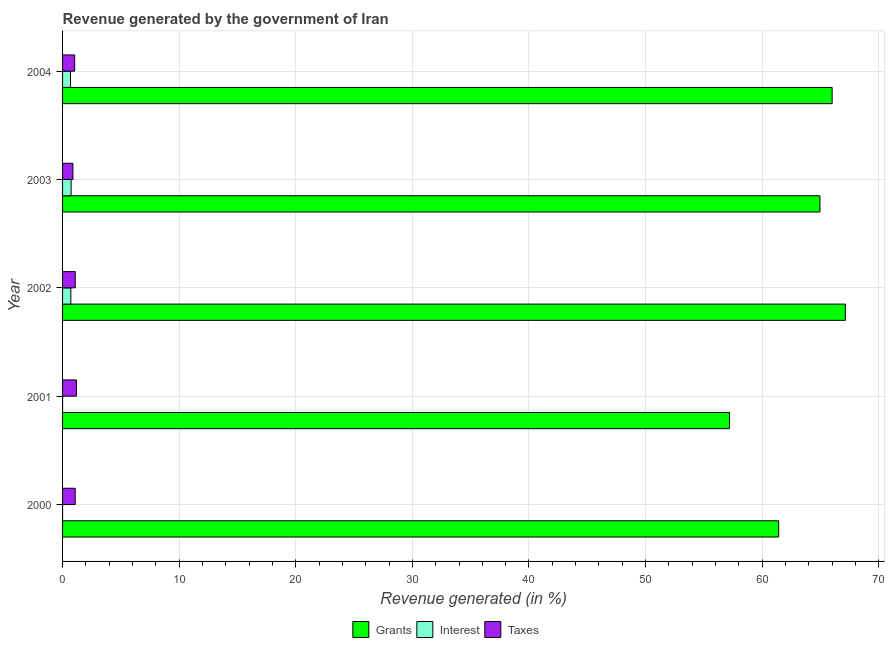How many different coloured bars are there?
Keep it short and to the point. 3. How many groups of bars are there?
Make the answer very short. 5. How many bars are there on the 2nd tick from the top?
Make the answer very short. 3. How many bars are there on the 2nd tick from the bottom?
Make the answer very short. 3. What is the label of the 1st group of bars from the top?
Your response must be concise. 2004. What is the percentage of revenue generated by grants in 2002?
Keep it short and to the point. 67.13. Across all years, what is the maximum percentage of revenue generated by grants?
Your answer should be compact. 67.13. Across all years, what is the minimum percentage of revenue generated by grants?
Keep it short and to the point. 57.2. What is the total percentage of revenue generated by interest in the graph?
Offer a very short reply. 2.12. What is the difference between the percentage of revenue generated by taxes in 2002 and that in 2004?
Ensure brevity in your answer.  0.05. What is the difference between the percentage of revenue generated by grants in 2002 and the percentage of revenue generated by taxes in 2004?
Ensure brevity in your answer.  66.1. What is the average percentage of revenue generated by taxes per year?
Your answer should be very brief. 1.06. In the year 2002, what is the difference between the percentage of revenue generated by grants and percentage of revenue generated by taxes?
Your answer should be compact. 66.05. In how many years, is the percentage of revenue generated by grants greater than 36 %?
Your answer should be very brief. 5. What is the ratio of the percentage of revenue generated by taxes in 2003 to that in 2004?
Make the answer very short. 0.85. What is the difference between the highest and the second highest percentage of revenue generated by grants?
Make the answer very short. 1.13. What is the difference between the highest and the lowest percentage of revenue generated by interest?
Provide a succinct answer. 0.73. What does the 2nd bar from the top in 2002 represents?
Provide a short and direct response. Interest. What does the 3rd bar from the bottom in 2001 represents?
Provide a succinct answer. Taxes. Is it the case that in every year, the sum of the percentage of revenue generated by grants and percentage of revenue generated by interest is greater than the percentage of revenue generated by taxes?
Provide a short and direct response. Yes. Does the graph contain grids?
Provide a succinct answer. Yes. Where does the legend appear in the graph?
Keep it short and to the point. Bottom center. How many legend labels are there?
Your response must be concise. 3. How are the legend labels stacked?
Offer a terse response. Horizontal. What is the title of the graph?
Give a very brief answer. Revenue generated by the government of Iran. Does "Czech Republic" appear as one of the legend labels in the graph?
Your answer should be very brief. No. What is the label or title of the X-axis?
Your response must be concise. Revenue generated (in %). What is the label or title of the Y-axis?
Offer a terse response. Year. What is the Revenue generated (in %) in Grants in 2000?
Your answer should be compact. 61.42. What is the Revenue generated (in %) of Interest in 2000?
Keep it short and to the point. 5.52099100195348e-5. What is the Revenue generated (in %) in Taxes in 2000?
Your answer should be very brief. 1.08. What is the Revenue generated (in %) of Grants in 2001?
Ensure brevity in your answer.  57.2. What is the Revenue generated (in %) in Interest in 2001?
Give a very brief answer. 7.09598447964424e-5. What is the Revenue generated (in %) of Taxes in 2001?
Ensure brevity in your answer.  1.19. What is the Revenue generated (in %) in Grants in 2002?
Your answer should be very brief. 67.13. What is the Revenue generated (in %) of Interest in 2002?
Your answer should be compact. 0.71. What is the Revenue generated (in %) of Taxes in 2002?
Give a very brief answer. 1.09. What is the Revenue generated (in %) in Grants in 2003?
Offer a very short reply. 64.95. What is the Revenue generated (in %) of Interest in 2003?
Offer a very short reply. 0.73. What is the Revenue generated (in %) of Taxes in 2003?
Ensure brevity in your answer.  0.89. What is the Revenue generated (in %) in Grants in 2004?
Make the answer very short. 66. What is the Revenue generated (in %) of Interest in 2004?
Keep it short and to the point. 0.68. What is the Revenue generated (in %) of Taxes in 2004?
Your answer should be compact. 1.04. Across all years, what is the maximum Revenue generated (in %) in Grants?
Your answer should be very brief. 67.13. Across all years, what is the maximum Revenue generated (in %) of Interest?
Your answer should be very brief. 0.73. Across all years, what is the maximum Revenue generated (in %) in Taxes?
Offer a terse response. 1.19. Across all years, what is the minimum Revenue generated (in %) in Grants?
Keep it short and to the point. 57.2. Across all years, what is the minimum Revenue generated (in %) in Interest?
Give a very brief answer. 5.52099100195348e-5. Across all years, what is the minimum Revenue generated (in %) of Taxes?
Provide a short and direct response. 0.89. What is the total Revenue generated (in %) in Grants in the graph?
Your response must be concise. 316.7. What is the total Revenue generated (in %) of Interest in the graph?
Offer a very short reply. 2.12. What is the total Revenue generated (in %) in Taxes in the graph?
Ensure brevity in your answer.  5.29. What is the difference between the Revenue generated (in %) of Grants in 2000 and that in 2001?
Make the answer very short. 4.22. What is the difference between the Revenue generated (in %) of Interest in 2000 and that in 2001?
Give a very brief answer. -0. What is the difference between the Revenue generated (in %) of Taxes in 2000 and that in 2001?
Ensure brevity in your answer.  -0.11. What is the difference between the Revenue generated (in %) of Grants in 2000 and that in 2002?
Your response must be concise. -5.72. What is the difference between the Revenue generated (in %) of Interest in 2000 and that in 2002?
Your answer should be compact. -0.71. What is the difference between the Revenue generated (in %) in Taxes in 2000 and that in 2002?
Give a very brief answer. -0.01. What is the difference between the Revenue generated (in %) in Grants in 2000 and that in 2003?
Provide a succinct answer. -3.54. What is the difference between the Revenue generated (in %) of Interest in 2000 and that in 2003?
Ensure brevity in your answer.  -0.73. What is the difference between the Revenue generated (in %) in Taxes in 2000 and that in 2003?
Offer a terse response. 0.19. What is the difference between the Revenue generated (in %) in Grants in 2000 and that in 2004?
Your response must be concise. -4.58. What is the difference between the Revenue generated (in %) in Interest in 2000 and that in 2004?
Your response must be concise. -0.68. What is the difference between the Revenue generated (in %) in Taxes in 2000 and that in 2004?
Make the answer very short. 0.04. What is the difference between the Revenue generated (in %) of Grants in 2001 and that in 2002?
Ensure brevity in your answer.  -9.94. What is the difference between the Revenue generated (in %) of Interest in 2001 and that in 2002?
Provide a succinct answer. -0.71. What is the difference between the Revenue generated (in %) in Taxes in 2001 and that in 2002?
Your answer should be compact. 0.1. What is the difference between the Revenue generated (in %) of Grants in 2001 and that in 2003?
Your answer should be very brief. -7.76. What is the difference between the Revenue generated (in %) in Interest in 2001 and that in 2003?
Offer a very short reply. -0.73. What is the difference between the Revenue generated (in %) of Taxes in 2001 and that in 2003?
Keep it short and to the point. 0.3. What is the difference between the Revenue generated (in %) in Grants in 2001 and that in 2004?
Make the answer very short. -8.81. What is the difference between the Revenue generated (in %) of Interest in 2001 and that in 2004?
Your response must be concise. -0.68. What is the difference between the Revenue generated (in %) of Taxes in 2001 and that in 2004?
Provide a short and direct response. 0.15. What is the difference between the Revenue generated (in %) in Grants in 2002 and that in 2003?
Provide a succinct answer. 2.18. What is the difference between the Revenue generated (in %) of Interest in 2002 and that in 2003?
Your answer should be very brief. -0.02. What is the difference between the Revenue generated (in %) of Taxes in 2002 and that in 2003?
Ensure brevity in your answer.  0.2. What is the difference between the Revenue generated (in %) in Grants in 2002 and that in 2004?
Provide a succinct answer. 1.13. What is the difference between the Revenue generated (in %) of Interest in 2002 and that in 2004?
Ensure brevity in your answer.  0.03. What is the difference between the Revenue generated (in %) of Taxes in 2002 and that in 2004?
Your answer should be compact. 0.05. What is the difference between the Revenue generated (in %) in Grants in 2003 and that in 2004?
Offer a terse response. -1.05. What is the difference between the Revenue generated (in %) of Interest in 2003 and that in 2004?
Provide a short and direct response. 0.05. What is the difference between the Revenue generated (in %) of Taxes in 2003 and that in 2004?
Your answer should be very brief. -0.15. What is the difference between the Revenue generated (in %) of Grants in 2000 and the Revenue generated (in %) of Interest in 2001?
Offer a very short reply. 61.42. What is the difference between the Revenue generated (in %) in Grants in 2000 and the Revenue generated (in %) in Taxes in 2001?
Make the answer very short. 60.23. What is the difference between the Revenue generated (in %) of Interest in 2000 and the Revenue generated (in %) of Taxes in 2001?
Ensure brevity in your answer.  -1.19. What is the difference between the Revenue generated (in %) in Grants in 2000 and the Revenue generated (in %) in Interest in 2002?
Give a very brief answer. 60.71. What is the difference between the Revenue generated (in %) of Grants in 2000 and the Revenue generated (in %) of Taxes in 2002?
Give a very brief answer. 60.33. What is the difference between the Revenue generated (in %) of Interest in 2000 and the Revenue generated (in %) of Taxes in 2002?
Provide a succinct answer. -1.09. What is the difference between the Revenue generated (in %) of Grants in 2000 and the Revenue generated (in %) of Interest in 2003?
Make the answer very short. 60.68. What is the difference between the Revenue generated (in %) in Grants in 2000 and the Revenue generated (in %) in Taxes in 2003?
Keep it short and to the point. 60.53. What is the difference between the Revenue generated (in %) in Interest in 2000 and the Revenue generated (in %) in Taxes in 2003?
Ensure brevity in your answer.  -0.89. What is the difference between the Revenue generated (in %) of Grants in 2000 and the Revenue generated (in %) of Interest in 2004?
Keep it short and to the point. 60.74. What is the difference between the Revenue generated (in %) in Grants in 2000 and the Revenue generated (in %) in Taxes in 2004?
Offer a terse response. 60.38. What is the difference between the Revenue generated (in %) of Interest in 2000 and the Revenue generated (in %) of Taxes in 2004?
Offer a terse response. -1.04. What is the difference between the Revenue generated (in %) in Grants in 2001 and the Revenue generated (in %) in Interest in 2002?
Keep it short and to the point. 56.49. What is the difference between the Revenue generated (in %) in Grants in 2001 and the Revenue generated (in %) in Taxes in 2002?
Your answer should be very brief. 56.11. What is the difference between the Revenue generated (in %) in Interest in 2001 and the Revenue generated (in %) in Taxes in 2002?
Make the answer very short. -1.09. What is the difference between the Revenue generated (in %) in Grants in 2001 and the Revenue generated (in %) in Interest in 2003?
Offer a terse response. 56.46. What is the difference between the Revenue generated (in %) of Grants in 2001 and the Revenue generated (in %) of Taxes in 2003?
Provide a succinct answer. 56.31. What is the difference between the Revenue generated (in %) of Interest in 2001 and the Revenue generated (in %) of Taxes in 2003?
Make the answer very short. -0.89. What is the difference between the Revenue generated (in %) of Grants in 2001 and the Revenue generated (in %) of Interest in 2004?
Provide a succinct answer. 56.51. What is the difference between the Revenue generated (in %) in Grants in 2001 and the Revenue generated (in %) in Taxes in 2004?
Offer a very short reply. 56.16. What is the difference between the Revenue generated (in %) of Interest in 2001 and the Revenue generated (in %) of Taxes in 2004?
Offer a terse response. -1.04. What is the difference between the Revenue generated (in %) in Grants in 2002 and the Revenue generated (in %) in Interest in 2003?
Offer a terse response. 66.4. What is the difference between the Revenue generated (in %) of Grants in 2002 and the Revenue generated (in %) of Taxes in 2003?
Provide a short and direct response. 66.25. What is the difference between the Revenue generated (in %) of Interest in 2002 and the Revenue generated (in %) of Taxes in 2003?
Offer a terse response. -0.18. What is the difference between the Revenue generated (in %) of Grants in 2002 and the Revenue generated (in %) of Interest in 2004?
Your answer should be very brief. 66.45. What is the difference between the Revenue generated (in %) in Grants in 2002 and the Revenue generated (in %) in Taxes in 2004?
Give a very brief answer. 66.1. What is the difference between the Revenue generated (in %) in Interest in 2002 and the Revenue generated (in %) in Taxes in 2004?
Your answer should be compact. -0.33. What is the difference between the Revenue generated (in %) of Grants in 2003 and the Revenue generated (in %) of Interest in 2004?
Keep it short and to the point. 64.27. What is the difference between the Revenue generated (in %) of Grants in 2003 and the Revenue generated (in %) of Taxes in 2004?
Keep it short and to the point. 63.92. What is the difference between the Revenue generated (in %) of Interest in 2003 and the Revenue generated (in %) of Taxes in 2004?
Ensure brevity in your answer.  -0.3. What is the average Revenue generated (in %) of Grants per year?
Offer a terse response. 63.34. What is the average Revenue generated (in %) of Interest per year?
Give a very brief answer. 0.42. What is the average Revenue generated (in %) in Taxes per year?
Provide a short and direct response. 1.06. In the year 2000, what is the difference between the Revenue generated (in %) in Grants and Revenue generated (in %) in Interest?
Ensure brevity in your answer.  61.42. In the year 2000, what is the difference between the Revenue generated (in %) of Grants and Revenue generated (in %) of Taxes?
Your answer should be very brief. 60.33. In the year 2000, what is the difference between the Revenue generated (in %) of Interest and Revenue generated (in %) of Taxes?
Ensure brevity in your answer.  -1.08. In the year 2001, what is the difference between the Revenue generated (in %) of Grants and Revenue generated (in %) of Interest?
Offer a very short reply. 57.2. In the year 2001, what is the difference between the Revenue generated (in %) in Grants and Revenue generated (in %) in Taxes?
Ensure brevity in your answer.  56. In the year 2001, what is the difference between the Revenue generated (in %) of Interest and Revenue generated (in %) of Taxes?
Provide a succinct answer. -1.19. In the year 2002, what is the difference between the Revenue generated (in %) of Grants and Revenue generated (in %) of Interest?
Your answer should be very brief. 66.42. In the year 2002, what is the difference between the Revenue generated (in %) of Grants and Revenue generated (in %) of Taxes?
Offer a terse response. 66.05. In the year 2002, what is the difference between the Revenue generated (in %) in Interest and Revenue generated (in %) in Taxes?
Your answer should be compact. -0.38. In the year 2003, what is the difference between the Revenue generated (in %) in Grants and Revenue generated (in %) in Interest?
Offer a terse response. 64.22. In the year 2003, what is the difference between the Revenue generated (in %) in Grants and Revenue generated (in %) in Taxes?
Provide a succinct answer. 64.07. In the year 2003, what is the difference between the Revenue generated (in %) in Interest and Revenue generated (in %) in Taxes?
Provide a succinct answer. -0.15. In the year 2004, what is the difference between the Revenue generated (in %) in Grants and Revenue generated (in %) in Interest?
Your answer should be very brief. 65.32. In the year 2004, what is the difference between the Revenue generated (in %) of Grants and Revenue generated (in %) of Taxes?
Your response must be concise. 64.96. In the year 2004, what is the difference between the Revenue generated (in %) of Interest and Revenue generated (in %) of Taxes?
Offer a very short reply. -0.36. What is the ratio of the Revenue generated (in %) of Grants in 2000 to that in 2001?
Offer a very short reply. 1.07. What is the ratio of the Revenue generated (in %) of Interest in 2000 to that in 2001?
Your response must be concise. 0.78. What is the ratio of the Revenue generated (in %) in Taxes in 2000 to that in 2001?
Offer a very short reply. 0.91. What is the ratio of the Revenue generated (in %) in Grants in 2000 to that in 2002?
Your response must be concise. 0.91. What is the ratio of the Revenue generated (in %) of Interest in 2000 to that in 2002?
Your response must be concise. 0. What is the ratio of the Revenue generated (in %) in Taxes in 2000 to that in 2002?
Your answer should be very brief. 0.99. What is the ratio of the Revenue generated (in %) in Grants in 2000 to that in 2003?
Ensure brevity in your answer.  0.95. What is the ratio of the Revenue generated (in %) in Interest in 2000 to that in 2003?
Ensure brevity in your answer.  0. What is the ratio of the Revenue generated (in %) of Taxes in 2000 to that in 2003?
Your answer should be very brief. 1.22. What is the ratio of the Revenue generated (in %) in Grants in 2000 to that in 2004?
Your answer should be compact. 0.93. What is the ratio of the Revenue generated (in %) of Interest in 2000 to that in 2004?
Your answer should be compact. 0. What is the ratio of the Revenue generated (in %) in Taxes in 2000 to that in 2004?
Your answer should be very brief. 1.04. What is the ratio of the Revenue generated (in %) of Grants in 2001 to that in 2002?
Offer a very short reply. 0.85. What is the ratio of the Revenue generated (in %) in Interest in 2001 to that in 2002?
Offer a very short reply. 0. What is the ratio of the Revenue generated (in %) of Taxes in 2001 to that in 2002?
Ensure brevity in your answer.  1.09. What is the ratio of the Revenue generated (in %) in Grants in 2001 to that in 2003?
Keep it short and to the point. 0.88. What is the ratio of the Revenue generated (in %) of Taxes in 2001 to that in 2003?
Your response must be concise. 1.34. What is the ratio of the Revenue generated (in %) in Grants in 2001 to that in 2004?
Keep it short and to the point. 0.87. What is the ratio of the Revenue generated (in %) in Taxes in 2001 to that in 2004?
Your answer should be very brief. 1.15. What is the ratio of the Revenue generated (in %) in Grants in 2002 to that in 2003?
Offer a terse response. 1.03. What is the ratio of the Revenue generated (in %) in Interest in 2002 to that in 2003?
Your response must be concise. 0.97. What is the ratio of the Revenue generated (in %) of Taxes in 2002 to that in 2003?
Give a very brief answer. 1.23. What is the ratio of the Revenue generated (in %) of Grants in 2002 to that in 2004?
Your response must be concise. 1.02. What is the ratio of the Revenue generated (in %) in Interest in 2002 to that in 2004?
Ensure brevity in your answer.  1.04. What is the ratio of the Revenue generated (in %) in Taxes in 2002 to that in 2004?
Keep it short and to the point. 1.05. What is the ratio of the Revenue generated (in %) in Grants in 2003 to that in 2004?
Provide a short and direct response. 0.98. What is the ratio of the Revenue generated (in %) of Interest in 2003 to that in 2004?
Your response must be concise. 1.08. What is the ratio of the Revenue generated (in %) of Taxes in 2003 to that in 2004?
Keep it short and to the point. 0.86. What is the difference between the highest and the second highest Revenue generated (in %) of Grants?
Make the answer very short. 1.13. What is the difference between the highest and the second highest Revenue generated (in %) of Interest?
Your answer should be very brief. 0.02. What is the difference between the highest and the second highest Revenue generated (in %) of Taxes?
Your response must be concise. 0.1. What is the difference between the highest and the lowest Revenue generated (in %) of Grants?
Your answer should be compact. 9.94. What is the difference between the highest and the lowest Revenue generated (in %) in Interest?
Your answer should be compact. 0.73. What is the difference between the highest and the lowest Revenue generated (in %) in Taxes?
Make the answer very short. 0.3. 